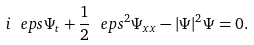<formula> <loc_0><loc_0><loc_500><loc_500>i \ e p s \Psi _ { t } + \frac { 1 } { 2 } \ e p s ^ { 2 } \Psi _ { x x } - | \Psi | ^ { 2 } \Psi = 0 .</formula> 